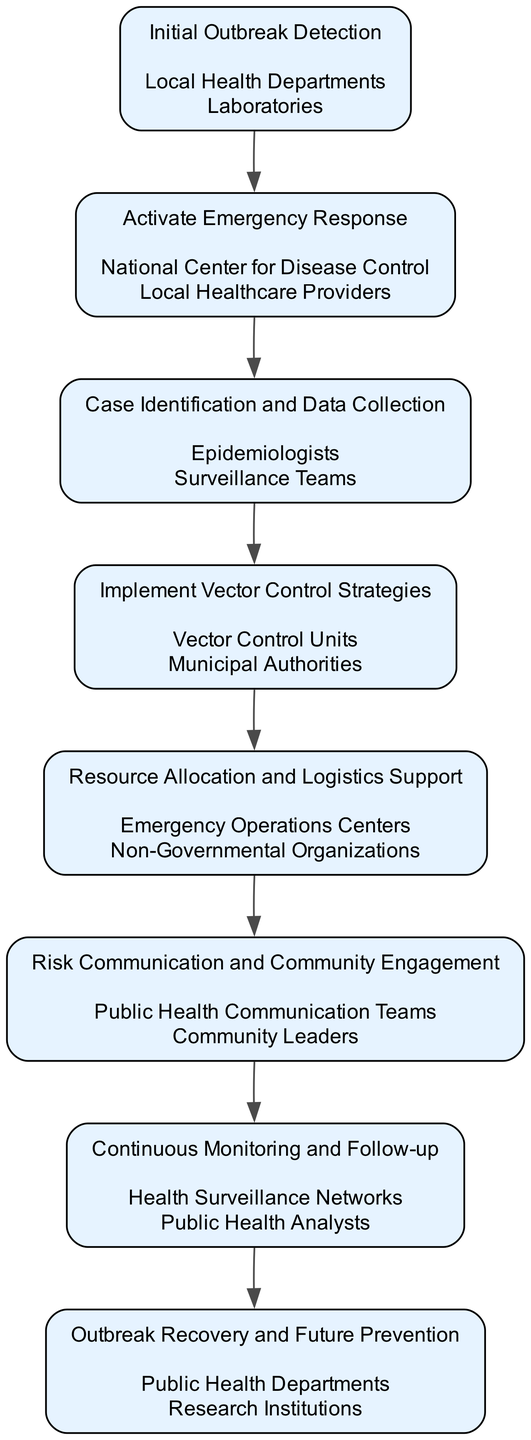What is the first action in the pathway? The first action listed in the diagram is "Initial Outbreak Detection," which indicates the start of the emergency response process.
Answer: Initial Outbreak Detection How many entities are involved in "Implement Vector Control Strategies"? The entities listed under "Implement Vector Control Strategies" are "Vector Control Units" and "Municipal Authorities." This counts as two entities involved.
Answer: 2 Who is responsible for "Resource Allocation and Logistics Support"? The action "Resource Allocation and Logistics Support" is conducted by "Emergency Operations Centers" and "Non-Governmental Organizations," indicating they are responsible for this function.
Answer: Emergency Operations Centers and Non-Governmental Organizations What is the key focus during the "Monitoring and Evaluation" stage? The key focus during "Monitoring and Evaluation" is on "Continuous Monitoring and Follow-up," which suggests an ongoing assessment of the response measures implemented earlier.
Answer: Continuous Monitoring and Follow-up Which stage involves "Public Health Communication Teams"? The stage that involves "Public Health Communication Teams" is "Risk Communication and Community Engagement," where timely information is conveyed to the public.
Answer: Risk Communication and Community Engagement What follows "Case Identification and Data Collection" in the pathway? Following "Case Identification and Data Collection," the next step in the pathway is "Implement Vector Control Strategies," indicating a progression from understanding cases to taking preventive action.
Answer: Implement Vector Control Strategies Which entities are involved in "Alert and Notification"? The entities involved in "Alert and Notification" are "National Center for Disease Control" and "Local Healthcare Providers," highlighting stakeholders in emergency response communication.
Answer: National Center for Disease Control and Local Healthcare Providers Identify a stage that ensures community health services are restored. The stage that focuses on restoring community health services is "Outbreak Recovery and Future Prevention," indicating efforts to return to normalcy after an outbreak.
Answer: Outbreak Recovery and Future Prevention What is the purpose of "Initial Outbreak Detection"? The purpose of "Initial Outbreak Detection" is to "Confirm diagnosis and verify outbreak through laboratory testing," assessing whether there is indeed an outbreak.
Answer: Confirm diagnosis and verify outbreak through laboratory testing 